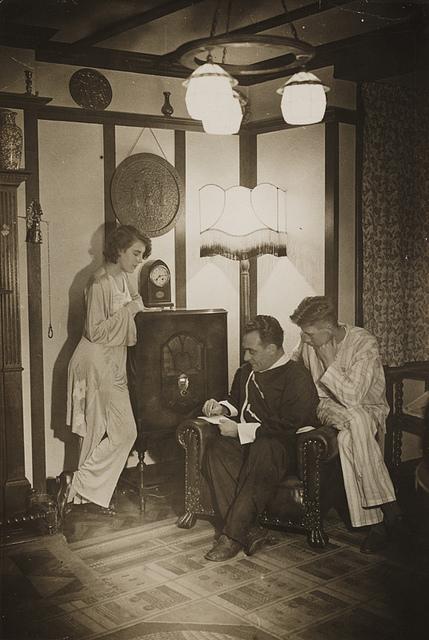Was this picture recently taken?
Concise answer only. No. Who is the head of the household?
Short answer required. Man. What color is the photo?
Quick response, please. Black and white. What instrument in the second from the left holding?
Quick response, please. Pen. 